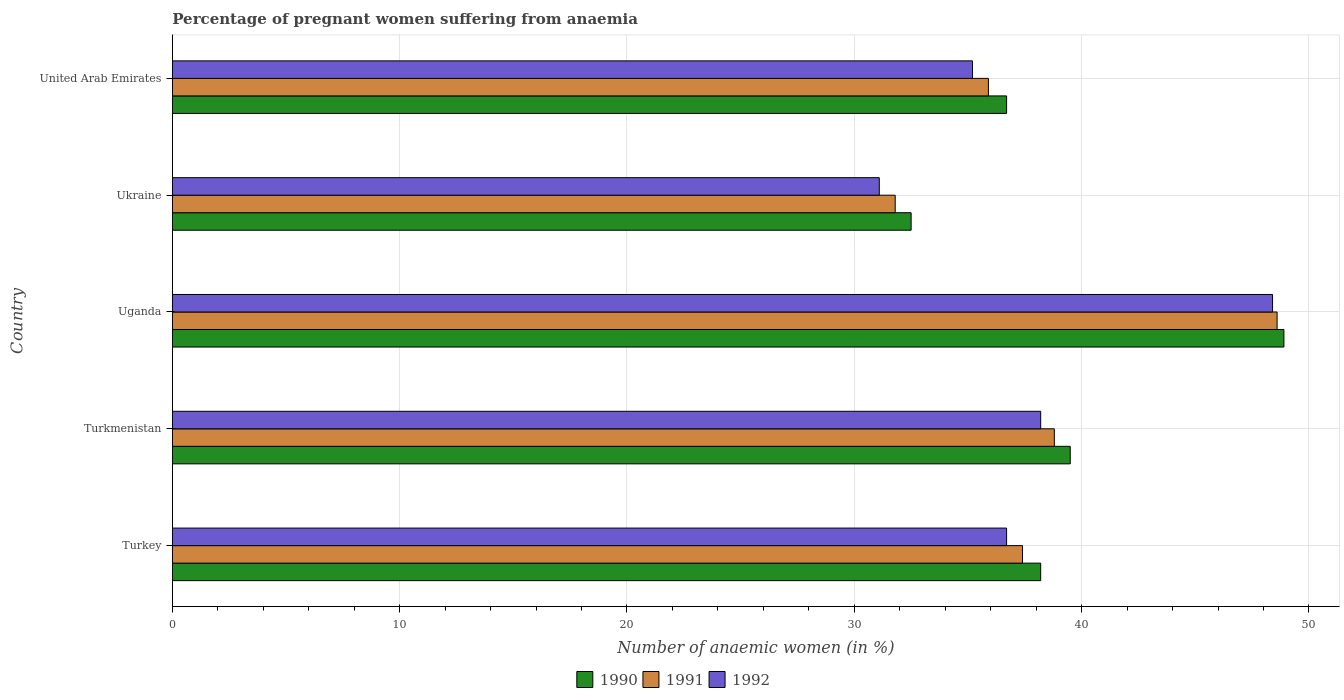How many groups of bars are there?
Offer a very short reply. 5. Are the number of bars on each tick of the Y-axis equal?
Provide a short and direct response. Yes. What is the label of the 4th group of bars from the top?
Offer a very short reply. Turkmenistan. What is the number of anaemic women in 1991 in Turkmenistan?
Give a very brief answer. 38.8. Across all countries, what is the maximum number of anaemic women in 1991?
Ensure brevity in your answer.  48.6. Across all countries, what is the minimum number of anaemic women in 1990?
Offer a very short reply. 32.5. In which country was the number of anaemic women in 1990 maximum?
Make the answer very short. Uganda. In which country was the number of anaemic women in 1990 minimum?
Your answer should be very brief. Ukraine. What is the total number of anaemic women in 1992 in the graph?
Offer a very short reply. 189.6. What is the difference between the number of anaemic women in 1992 in Turkmenistan and that in Uganda?
Keep it short and to the point. -10.2. What is the difference between the number of anaemic women in 1990 in Turkmenistan and the number of anaemic women in 1992 in Ukraine?
Give a very brief answer. 8.4. What is the average number of anaemic women in 1990 per country?
Your answer should be very brief. 39.16. What is the difference between the number of anaemic women in 1990 and number of anaemic women in 1991 in Ukraine?
Your answer should be compact. 0.7. In how many countries, is the number of anaemic women in 1991 greater than 40 %?
Keep it short and to the point. 1. What is the ratio of the number of anaemic women in 1992 in Turkey to that in Uganda?
Your response must be concise. 0.76. Is the difference between the number of anaemic women in 1990 in Uganda and Ukraine greater than the difference between the number of anaemic women in 1991 in Uganda and Ukraine?
Provide a succinct answer. No. What is the difference between the highest and the second highest number of anaemic women in 1991?
Your response must be concise. 9.8. What is the difference between the highest and the lowest number of anaemic women in 1990?
Ensure brevity in your answer.  16.4. In how many countries, is the number of anaemic women in 1990 greater than the average number of anaemic women in 1990 taken over all countries?
Your answer should be very brief. 2. What does the 3rd bar from the top in Uganda represents?
Your response must be concise. 1990. Is it the case that in every country, the sum of the number of anaemic women in 1991 and number of anaemic women in 1990 is greater than the number of anaemic women in 1992?
Your response must be concise. Yes. What is the difference between two consecutive major ticks on the X-axis?
Your answer should be very brief. 10. Are the values on the major ticks of X-axis written in scientific E-notation?
Make the answer very short. No. How are the legend labels stacked?
Your answer should be compact. Horizontal. What is the title of the graph?
Give a very brief answer. Percentage of pregnant women suffering from anaemia. Does "1990" appear as one of the legend labels in the graph?
Ensure brevity in your answer.  Yes. What is the label or title of the X-axis?
Make the answer very short. Number of anaemic women (in %). What is the label or title of the Y-axis?
Make the answer very short. Country. What is the Number of anaemic women (in %) in 1990 in Turkey?
Ensure brevity in your answer.  38.2. What is the Number of anaemic women (in %) in 1991 in Turkey?
Ensure brevity in your answer.  37.4. What is the Number of anaemic women (in %) in 1992 in Turkey?
Provide a succinct answer. 36.7. What is the Number of anaemic women (in %) of 1990 in Turkmenistan?
Give a very brief answer. 39.5. What is the Number of anaemic women (in %) in 1991 in Turkmenistan?
Make the answer very short. 38.8. What is the Number of anaemic women (in %) of 1992 in Turkmenistan?
Ensure brevity in your answer.  38.2. What is the Number of anaemic women (in %) of 1990 in Uganda?
Provide a succinct answer. 48.9. What is the Number of anaemic women (in %) in 1991 in Uganda?
Give a very brief answer. 48.6. What is the Number of anaemic women (in %) in 1992 in Uganda?
Provide a short and direct response. 48.4. What is the Number of anaemic women (in %) of 1990 in Ukraine?
Provide a short and direct response. 32.5. What is the Number of anaemic women (in %) of 1991 in Ukraine?
Ensure brevity in your answer.  31.8. What is the Number of anaemic women (in %) in 1992 in Ukraine?
Make the answer very short. 31.1. What is the Number of anaemic women (in %) of 1990 in United Arab Emirates?
Your answer should be compact. 36.7. What is the Number of anaemic women (in %) in 1991 in United Arab Emirates?
Provide a short and direct response. 35.9. What is the Number of anaemic women (in %) of 1992 in United Arab Emirates?
Make the answer very short. 35.2. Across all countries, what is the maximum Number of anaemic women (in %) in 1990?
Keep it short and to the point. 48.9. Across all countries, what is the maximum Number of anaemic women (in %) of 1991?
Ensure brevity in your answer.  48.6. Across all countries, what is the maximum Number of anaemic women (in %) in 1992?
Your response must be concise. 48.4. Across all countries, what is the minimum Number of anaemic women (in %) in 1990?
Provide a succinct answer. 32.5. Across all countries, what is the minimum Number of anaemic women (in %) in 1991?
Offer a terse response. 31.8. Across all countries, what is the minimum Number of anaemic women (in %) of 1992?
Ensure brevity in your answer.  31.1. What is the total Number of anaemic women (in %) in 1990 in the graph?
Ensure brevity in your answer.  195.8. What is the total Number of anaemic women (in %) in 1991 in the graph?
Give a very brief answer. 192.5. What is the total Number of anaemic women (in %) of 1992 in the graph?
Your response must be concise. 189.6. What is the difference between the Number of anaemic women (in %) of 1990 in Turkey and that in Turkmenistan?
Give a very brief answer. -1.3. What is the difference between the Number of anaemic women (in %) in 1991 in Turkey and that in Turkmenistan?
Make the answer very short. -1.4. What is the difference between the Number of anaemic women (in %) in 1992 in Turkey and that in Turkmenistan?
Your answer should be compact. -1.5. What is the difference between the Number of anaemic women (in %) in 1990 in Turkey and that in Uganda?
Make the answer very short. -10.7. What is the difference between the Number of anaemic women (in %) in 1991 in Turkey and that in Uganda?
Offer a very short reply. -11.2. What is the difference between the Number of anaemic women (in %) of 1990 in Turkey and that in Ukraine?
Keep it short and to the point. 5.7. What is the difference between the Number of anaemic women (in %) in 1991 in Turkey and that in Ukraine?
Make the answer very short. 5.6. What is the difference between the Number of anaemic women (in %) of 1992 in Turkey and that in Ukraine?
Offer a very short reply. 5.6. What is the difference between the Number of anaemic women (in %) of 1991 in Turkey and that in United Arab Emirates?
Keep it short and to the point. 1.5. What is the difference between the Number of anaemic women (in %) in 1992 in Turkey and that in United Arab Emirates?
Ensure brevity in your answer.  1.5. What is the difference between the Number of anaemic women (in %) in 1990 in Turkmenistan and that in Ukraine?
Offer a very short reply. 7. What is the difference between the Number of anaemic women (in %) in 1991 in Turkmenistan and that in Ukraine?
Give a very brief answer. 7. What is the difference between the Number of anaemic women (in %) of 1990 in Uganda and that in Ukraine?
Make the answer very short. 16.4. What is the difference between the Number of anaemic women (in %) of 1990 in Turkey and the Number of anaemic women (in %) of 1992 in Turkmenistan?
Provide a short and direct response. 0. What is the difference between the Number of anaemic women (in %) of 1991 in Turkey and the Number of anaemic women (in %) of 1992 in Turkmenistan?
Your response must be concise. -0.8. What is the difference between the Number of anaemic women (in %) of 1991 in Turkey and the Number of anaemic women (in %) of 1992 in Uganda?
Provide a short and direct response. -11. What is the difference between the Number of anaemic women (in %) of 1990 in Turkey and the Number of anaemic women (in %) of 1991 in Ukraine?
Give a very brief answer. 6.4. What is the difference between the Number of anaemic women (in %) of 1990 in Turkey and the Number of anaemic women (in %) of 1992 in Ukraine?
Keep it short and to the point. 7.1. What is the difference between the Number of anaemic women (in %) of 1991 in Turkey and the Number of anaemic women (in %) of 1992 in Ukraine?
Provide a succinct answer. 6.3. What is the difference between the Number of anaemic women (in %) of 1990 in Turkey and the Number of anaemic women (in %) of 1991 in United Arab Emirates?
Give a very brief answer. 2.3. What is the difference between the Number of anaemic women (in %) of 1991 in Turkey and the Number of anaemic women (in %) of 1992 in United Arab Emirates?
Provide a short and direct response. 2.2. What is the difference between the Number of anaemic women (in %) in 1990 in Turkmenistan and the Number of anaemic women (in %) in 1991 in Uganda?
Offer a very short reply. -9.1. What is the difference between the Number of anaemic women (in %) of 1991 in Turkmenistan and the Number of anaemic women (in %) of 1992 in Uganda?
Your response must be concise. -9.6. What is the difference between the Number of anaemic women (in %) of 1990 in Turkmenistan and the Number of anaemic women (in %) of 1991 in Ukraine?
Offer a very short reply. 7.7. What is the difference between the Number of anaemic women (in %) in 1991 in Turkmenistan and the Number of anaemic women (in %) in 1992 in Ukraine?
Your response must be concise. 7.7. What is the difference between the Number of anaemic women (in %) in 1990 in Turkmenistan and the Number of anaemic women (in %) in 1991 in United Arab Emirates?
Your answer should be very brief. 3.6. What is the difference between the Number of anaemic women (in %) of 1990 in Turkmenistan and the Number of anaemic women (in %) of 1992 in United Arab Emirates?
Make the answer very short. 4.3. What is the difference between the Number of anaemic women (in %) in 1990 in Uganda and the Number of anaemic women (in %) in 1991 in Ukraine?
Provide a succinct answer. 17.1. What is the difference between the Number of anaemic women (in %) of 1990 in Uganda and the Number of anaemic women (in %) of 1992 in Ukraine?
Your answer should be compact. 17.8. What is the difference between the Number of anaemic women (in %) in 1990 in Uganda and the Number of anaemic women (in %) in 1991 in United Arab Emirates?
Offer a terse response. 13. What is the difference between the Number of anaemic women (in %) of 1990 in Uganda and the Number of anaemic women (in %) of 1992 in United Arab Emirates?
Make the answer very short. 13.7. What is the difference between the Number of anaemic women (in %) in 1991 in Uganda and the Number of anaemic women (in %) in 1992 in United Arab Emirates?
Provide a succinct answer. 13.4. What is the difference between the Number of anaemic women (in %) in 1990 in Ukraine and the Number of anaemic women (in %) in 1991 in United Arab Emirates?
Offer a very short reply. -3.4. What is the difference between the Number of anaemic women (in %) in 1991 in Ukraine and the Number of anaemic women (in %) in 1992 in United Arab Emirates?
Your answer should be compact. -3.4. What is the average Number of anaemic women (in %) of 1990 per country?
Offer a terse response. 39.16. What is the average Number of anaemic women (in %) in 1991 per country?
Your answer should be compact. 38.5. What is the average Number of anaemic women (in %) in 1992 per country?
Offer a very short reply. 37.92. What is the difference between the Number of anaemic women (in %) of 1990 and Number of anaemic women (in %) of 1992 in Turkey?
Your answer should be compact. 1.5. What is the difference between the Number of anaemic women (in %) in 1990 and Number of anaemic women (in %) in 1992 in Turkmenistan?
Keep it short and to the point. 1.3. What is the difference between the Number of anaemic women (in %) of 1991 and Number of anaemic women (in %) of 1992 in Turkmenistan?
Make the answer very short. 0.6. What is the difference between the Number of anaemic women (in %) of 1990 and Number of anaemic women (in %) of 1992 in Uganda?
Keep it short and to the point. 0.5. What is the difference between the Number of anaemic women (in %) of 1991 and Number of anaemic women (in %) of 1992 in Uganda?
Give a very brief answer. 0.2. What is the difference between the Number of anaemic women (in %) in 1991 and Number of anaemic women (in %) in 1992 in Ukraine?
Give a very brief answer. 0.7. What is the difference between the Number of anaemic women (in %) in 1991 and Number of anaemic women (in %) in 1992 in United Arab Emirates?
Your response must be concise. 0.7. What is the ratio of the Number of anaemic women (in %) of 1990 in Turkey to that in Turkmenistan?
Offer a terse response. 0.97. What is the ratio of the Number of anaemic women (in %) in 1991 in Turkey to that in Turkmenistan?
Offer a terse response. 0.96. What is the ratio of the Number of anaemic women (in %) of 1992 in Turkey to that in Turkmenistan?
Ensure brevity in your answer.  0.96. What is the ratio of the Number of anaemic women (in %) in 1990 in Turkey to that in Uganda?
Keep it short and to the point. 0.78. What is the ratio of the Number of anaemic women (in %) in 1991 in Turkey to that in Uganda?
Ensure brevity in your answer.  0.77. What is the ratio of the Number of anaemic women (in %) of 1992 in Turkey to that in Uganda?
Your response must be concise. 0.76. What is the ratio of the Number of anaemic women (in %) in 1990 in Turkey to that in Ukraine?
Your answer should be very brief. 1.18. What is the ratio of the Number of anaemic women (in %) of 1991 in Turkey to that in Ukraine?
Provide a succinct answer. 1.18. What is the ratio of the Number of anaemic women (in %) in 1992 in Turkey to that in Ukraine?
Make the answer very short. 1.18. What is the ratio of the Number of anaemic women (in %) in 1990 in Turkey to that in United Arab Emirates?
Make the answer very short. 1.04. What is the ratio of the Number of anaemic women (in %) of 1991 in Turkey to that in United Arab Emirates?
Keep it short and to the point. 1.04. What is the ratio of the Number of anaemic women (in %) of 1992 in Turkey to that in United Arab Emirates?
Your answer should be compact. 1.04. What is the ratio of the Number of anaemic women (in %) in 1990 in Turkmenistan to that in Uganda?
Offer a terse response. 0.81. What is the ratio of the Number of anaemic women (in %) in 1991 in Turkmenistan to that in Uganda?
Give a very brief answer. 0.8. What is the ratio of the Number of anaemic women (in %) of 1992 in Turkmenistan to that in Uganda?
Ensure brevity in your answer.  0.79. What is the ratio of the Number of anaemic women (in %) in 1990 in Turkmenistan to that in Ukraine?
Offer a terse response. 1.22. What is the ratio of the Number of anaemic women (in %) of 1991 in Turkmenistan to that in Ukraine?
Your response must be concise. 1.22. What is the ratio of the Number of anaemic women (in %) of 1992 in Turkmenistan to that in Ukraine?
Keep it short and to the point. 1.23. What is the ratio of the Number of anaemic women (in %) of 1990 in Turkmenistan to that in United Arab Emirates?
Make the answer very short. 1.08. What is the ratio of the Number of anaemic women (in %) in 1991 in Turkmenistan to that in United Arab Emirates?
Keep it short and to the point. 1.08. What is the ratio of the Number of anaemic women (in %) of 1992 in Turkmenistan to that in United Arab Emirates?
Ensure brevity in your answer.  1.09. What is the ratio of the Number of anaemic women (in %) of 1990 in Uganda to that in Ukraine?
Your response must be concise. 1.5. What is the ratio of the Number of anaemic women (in %) in 1991 in Uganda to that in Ukraine?
Offer a terse response. 1.53. What is the ratio of the Number of anaemic women (in %) of 1992 in Uganda to that in Ukraine?
Give a very brief answer. 1.56. What is the ratio of the Number of anaemic women (in %) in 1990 in Uganda to that in United Arab Emirates?
Ensure brevity in your answer.  1.33. What is the ratio of the Number of anaemic women (in %) of 1991 in Uganda to that in United Arab Emirates?
Keep it short and to the point. 1.35. What is the ratio of the Number of anaemic women (in %) in 1992 in Uganda to that in United Arab Emirates?
Offer a very short reply. 1.38. What is the ratio of the Number of anaemic women (in %) in 1990 in Ukraine to that in United Arab Emirates?
Your response must be concise. 0.89. What is the ratio of the Number of anaemic women (in %) in 1991 in Ukraine to that in United Arab Emirates?
Your answer should be compact. 0.89. What is the ratio of the Number of anaemic women (in %) of 1992 in Ukraine to that in United Arab Emirates?
Your response must be concise. 0.88. What is the difference between the highest and the second highest Number of anaemic women (in %) of 1990?
Make the answer very short. 9.4. What is the difference between the highest and the lowest Number of anaemic women (in %) in 1990?
Offer a very short reply. 16.4. What is the difference between the highest and the lowest Number of anaemic women (in %) of 1992?
Ensure brevity in your answer.  17.3. 